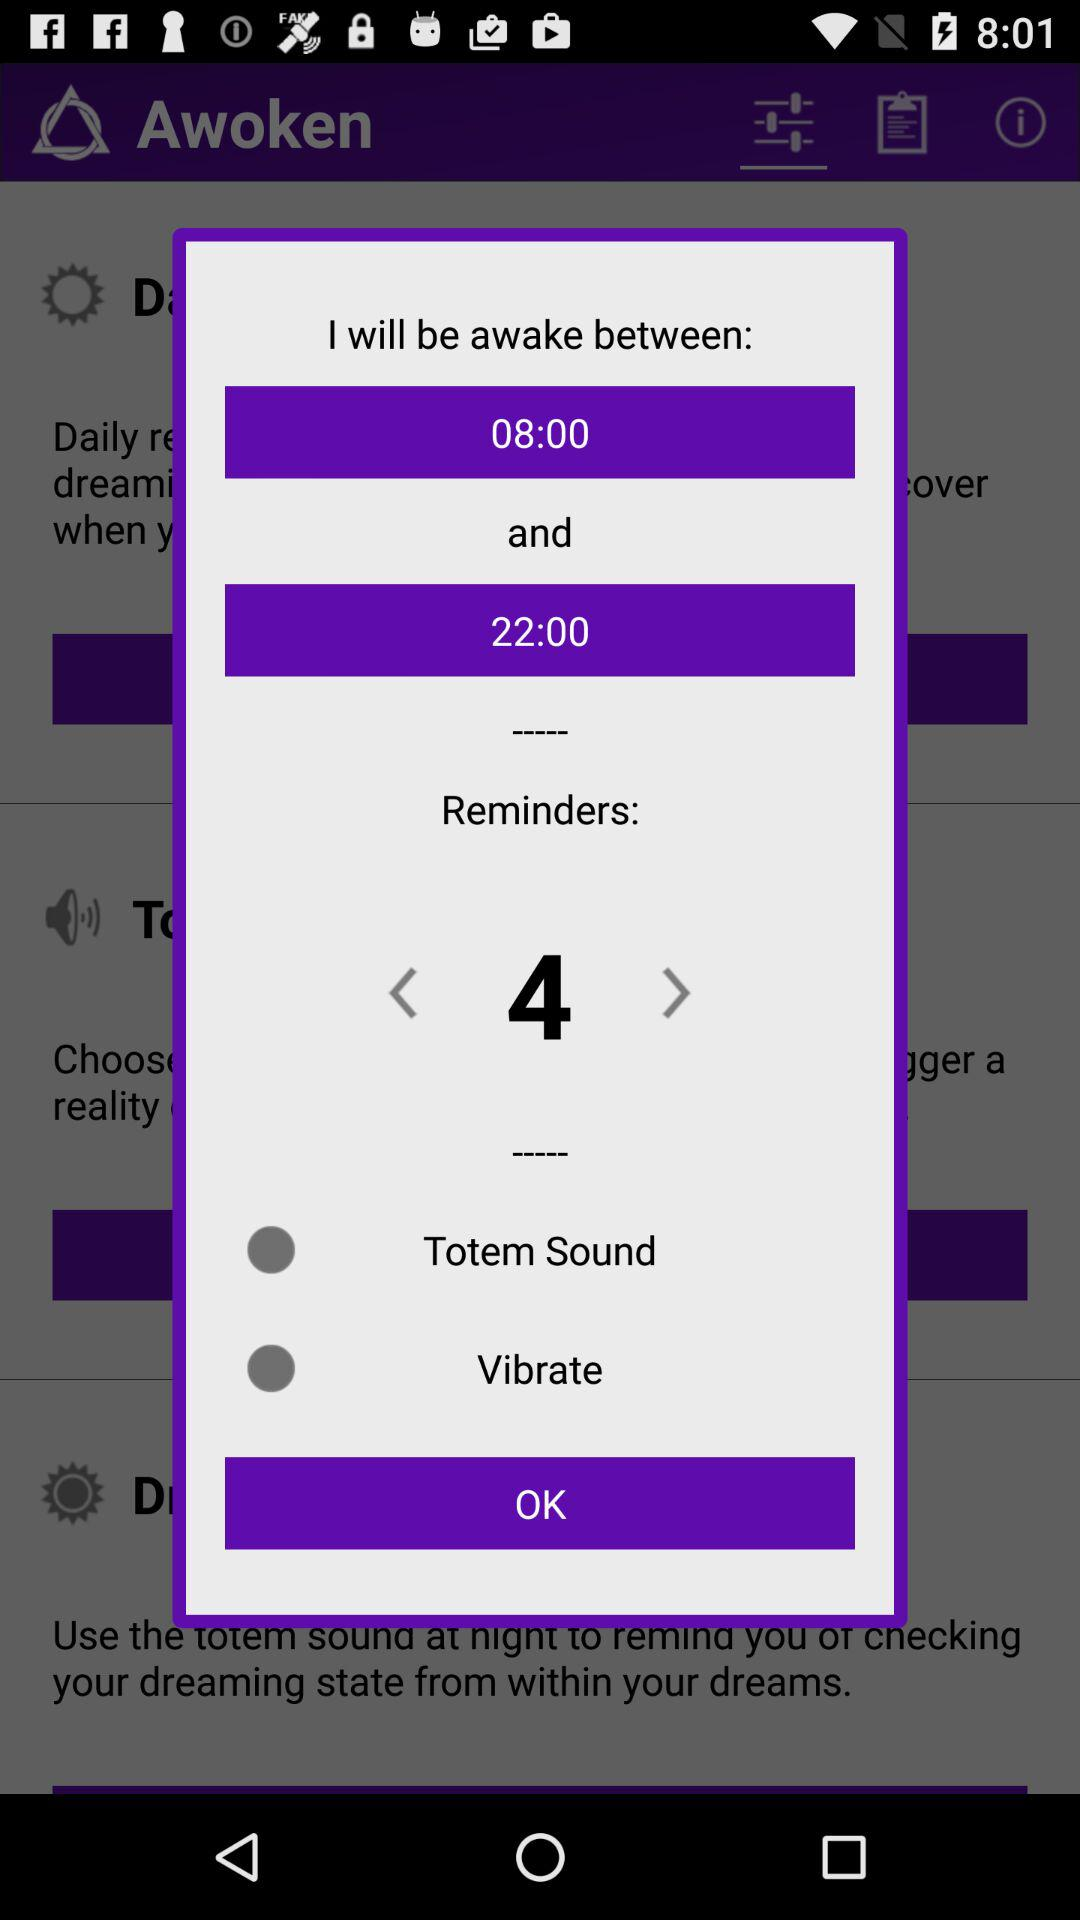How many reminders are there?
Answer the question using a single word or phrase. 4 